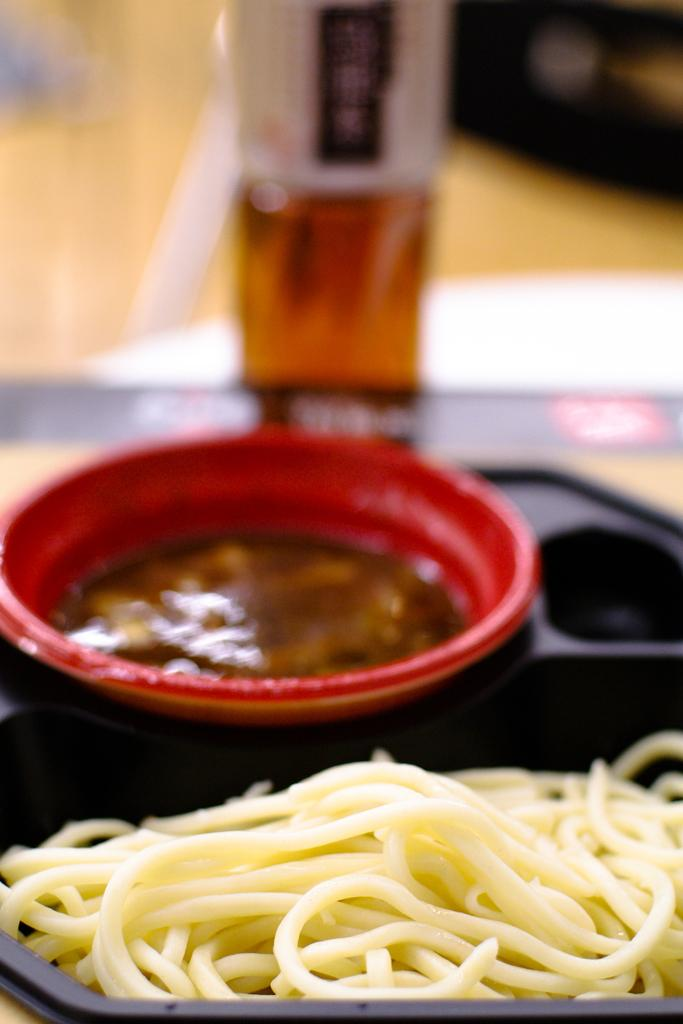What type of food is depicted in the image? There are noodles and soup in the image. How are the noodles and soup presented? The noodles and soup are in a plate. What riddle is being solved by the yarn in the meeting in the image? There is no riddle, yarn, or meeting present in the image. 